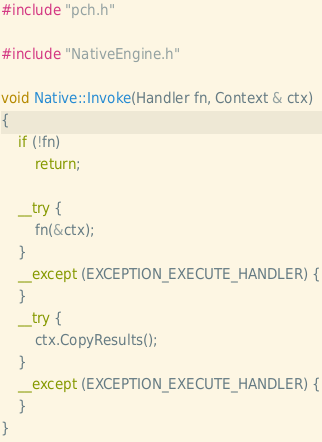Convert code to text. <code><loc_0><loc_0><loc_500><loc_500><_C++_>#include "pch.h"

#include "NativeEngine.h"

void Native::Invoke(Handler fn, Context & ctx)
{
	if (!fn)
		return;

	__try {
		fn(&ctx);
	}
	__except (EXCEPTION_EXECUTE_HANDLER) {
	}
	__try {
		ctx.CopyResults();
	}
	__except (EXCEPTION_EXECUTE_HANDLER) {
	}
}
</code> 